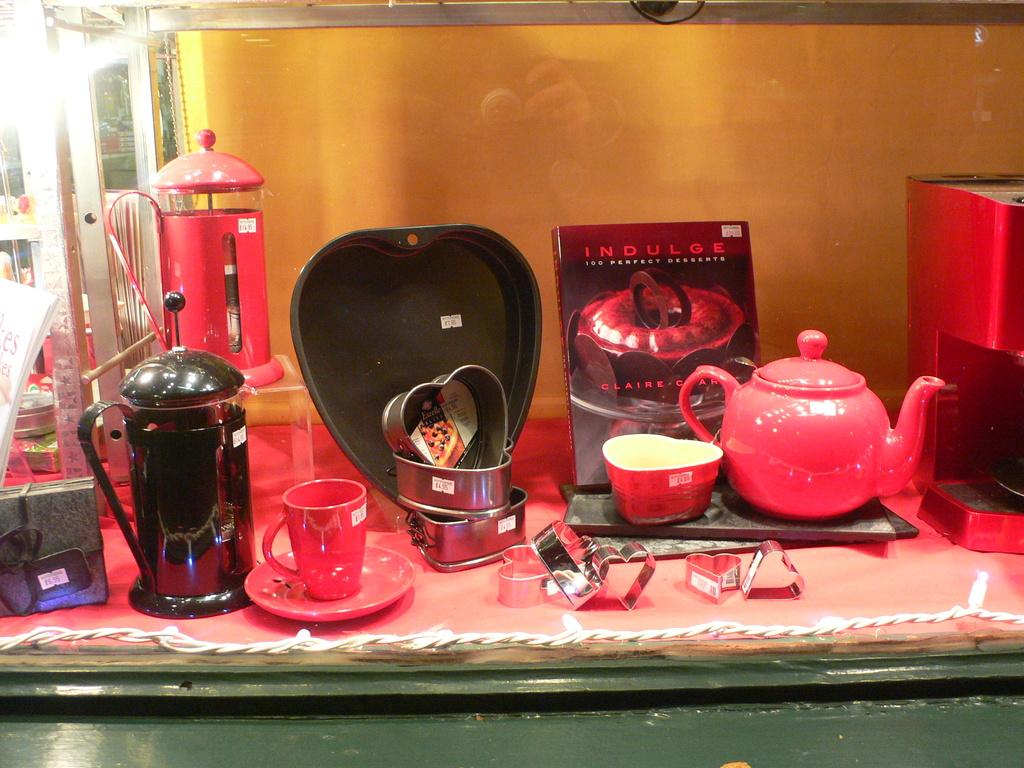What is the name of the book on display?
Ensure brevity in your answer.  Indulge. What is the author's first name?
Ensure brevity in your answer.  Claire. 